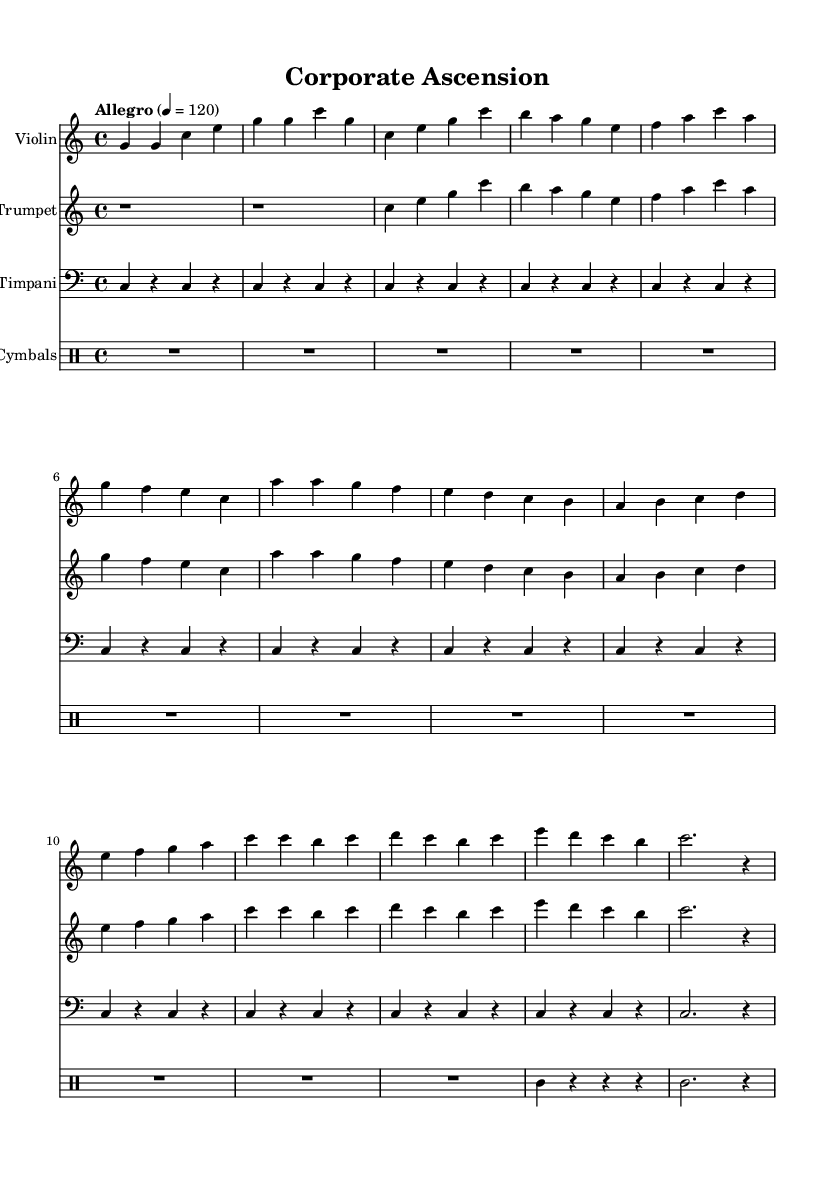What is the key signature of this music? The key signature is indicated at the beginning of the sheet music and is C major, which has no sharps or flats.
Answer: C major What is the time signature? The time signature is found at the beginning of the piece and indicates the rhythm; this sheet music shows 4/4, meaning there are four beats in each measure.
Answer: 4/4 What is the tempo marking? The tempo marking is expressly stated in the music and indicates how fast the piece should be played. Here, it specifies "Allegro," which typically suggests a lively and fast pace; it is set at a metronome marking of 120 beats per minute.
Answer: Allegro How many measures are in the main theme? By reviewing the music for the main theme section, which begins after the intro, we can see there are eight measures that define this thematic section. This can be counted directly in the notation.
Answer: 8 What instrument plays the climax? When checking the sheet music, the climax is played by both the violin and trumpet, as they are highlighted prominently in their individual staves during that section.
Answer: Violin and Trumpet Which instrument plays a continuous rhythm in the introduction? The introduction features a continuous rhythm primarily from the timpani, as it maintains a consistent note pattern throughout that section, creating a solid foundation.
Answer: Timpani What type of soundtrack is this music intended for? The sheet music is specifically labeled with the title "Corporate Ascension," indicating it is designed for corporate training videos, which typically require an uplifting and motivational sound.
Answer: Corporate training 